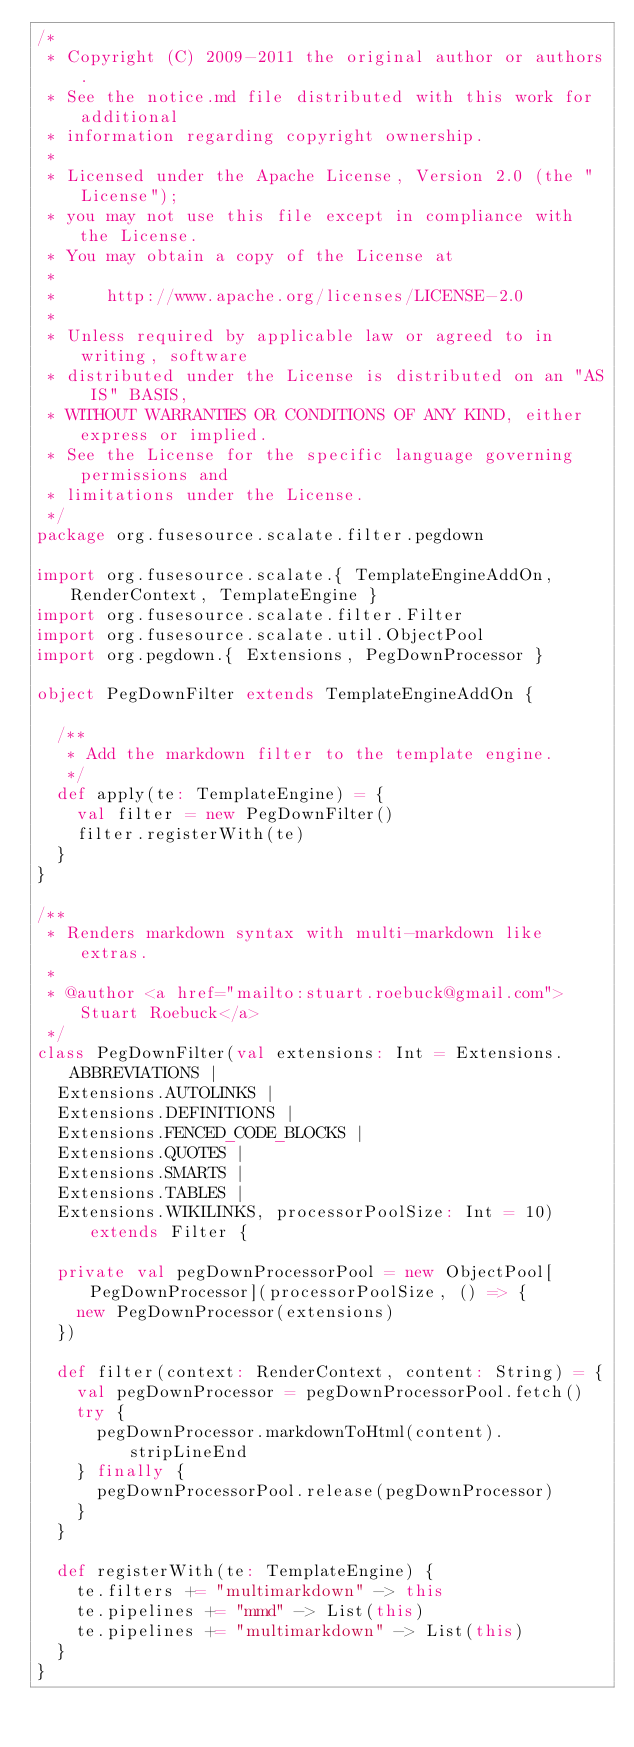<code> <loc_0><loc_0><loc_500><loc_500><_Scala_>/*
 * Copyright (C) 2009-2011 the original author or authors.
 * See the notice.md file distributed with this work for additional
 * information regarding copyright ownership.
 *
 * Licensed under the Apache License, Version 2.0 (the "License");
 * you may not use this file except in compliance with the License.
 * You may obtain a copy of the License at
 *
 *     http://www.apache.org/licenses/LICENSE-2.0
 *
 * Unless required by applicable law or agreed to in writing, software
 * distributed under the License is distributed on an "AS IS" BASIS,
 * WITHOUT WARRANTIES OR CONDITIONS OF ANY KIND, either express or implied.
 * See the License for the specific language governing permissions and
 * limitations under the License.
 */
package org.fusesource.scalate.filter.pegdown

import org.fusesource.scalate.{ TemplateEngineAddOn, RenderContext, TemplateEngine }
import org.fusesource.scalate.filter.Filter
import org.fusesource.scalate.util.ObjectPool
import org.pegdown.{ Extensions, PegDownProcessor }

object PegDownFilter extends TemplateEngineAddOn {

  /**
   * Add the markdown filter to the template engine.
   */
  def apply(te: TemplateEngine) = {
    val filter = new PegDownFilter()
    filter.registerWith(te)
  }
}

/**
 * Renders markdown syntax with multi-markdown like extras.
 *
 * @author <a href="mailto:stuart.roebuck@gmail.com">Stuart Roebuck</a>
 */
class PegDownFilter(val extensions: Int = Extensions.ABBREVIATIONS |
  Extensions.AUTOLINKS |
  Extensions.DEFINITIONS |
  Extensions.FENCED_CODE_BLOCKS |
  Extensions.QUOTES |
  Extensions.SMARTS |
  Extensions.TABLES |
  Extensions.WIKILINKS, processorPoolSize: Int = 10) extends Filter {

  private val pegDownProcessorPool = new ObjectPool[PegDownProcessor](processorPoolSize, () => {
    new PegDownProcessor(extensions)
  })

  def filter(context: RenderContext, content: String) = {
    val pegDownProcessor = pegDownProcessorPool.fetch()
    try {
      pegDownProcessor.markdownToHtml(content).stripLineEnd
    } finally {
      pegDownProcessorPool.release(pegDownProcessor)
    }
  }

  def registerWith(te: TemplateEngine) {
    te.filters += "multimarkdown" -> this
    te.pipelines += "mmd" -> List(this)
    te.pipelines += "multimarkdown" -> List(this)
  }
}
</code> 